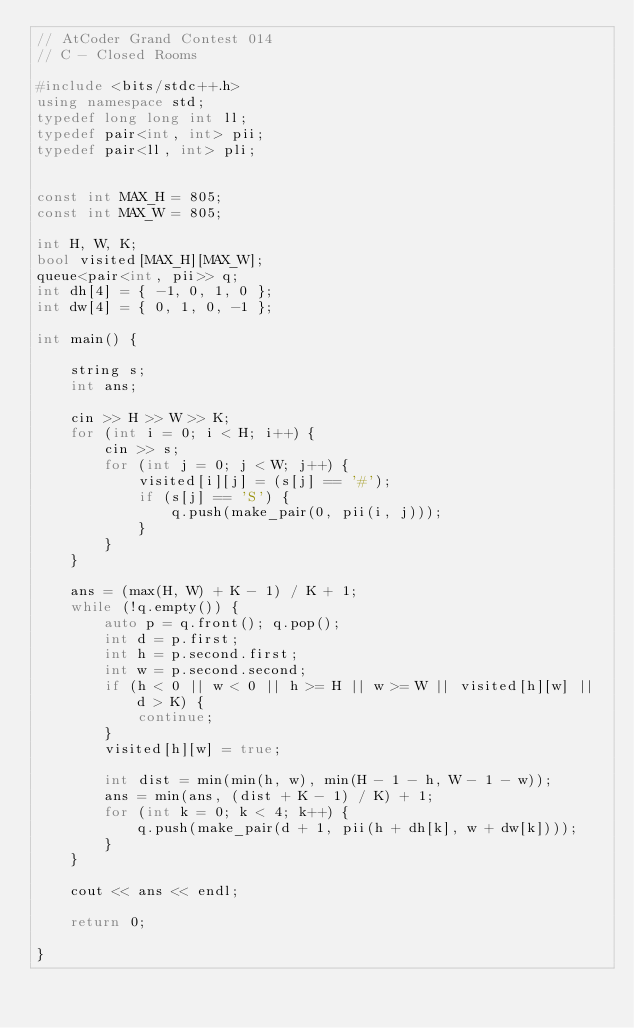Convert code to text. <code><loc_0><loc_0><loc_500><loc_500><_C++_>// AtCoder Grand Contest 014
// C - Closed Rooms

#include <bits/stdc++.h>
using namespace std;
typedef long long int ll;
typedef pair<int, int> pii;
typedef pair<ll, int> pli;


const int MAX_H = 805;
const int MAX_W = 805;

int H, W, K;
bool visited[MAX_H][MAX_W];
queue<pair<int, pii>> q;
int dh[4] = { -1, 0, 1, 0 };
int dw[4] = { 0, 1, 0, -1 };

int main() {

    string s;
    int ans;

    cin >> H >> W >> K;
    for (int i = 0; i < H; i++) {
        cin >> s;
        for (int j = 0; j < W; j++) {
            visited[i][j] = (s[j] == '#');
            if (s[j] == 'S') {
                q.push(make_pair(0, pii(i, j)));
            }
        }
    }

    ans = (max(H, W) + K - 1) / K + 1;
    while (!q.empty()) {
        auto p = q.front(); q.pop();
        int d = p.first;
        int h = p.second.first;
        int w = p.second.second;
        if (h < 0 || w < 0 || h >= H || w >= W || visited[h][w] || d > K) {
            continue;
        }
        visited[h][w] = true;

        int dist = min(min(h, w), min(H - 1 - h, W - 1 - w));
        ans = min(ans, (dist + K - 1) / K) + 1;
        for (int k = 0; k < 4; k++) {
            q.push(make_pair(d + 1, pii(h + dh[k], w + dw[k])));
        }
    }

    cout << ans << endl;

    return 0;

}



</code> 